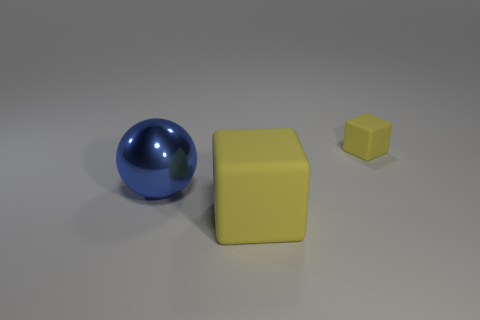What color is the big matte block?
Offer a terse response. Yellow. What is the color of the object on the right side of the yellow thing in front of the blue sphere?
Give a very brief answer. Yellow. There is a tiny block; does it have the same color as the matte object in front of the tiny rubber object?
Make the answer very short. Yes. What number of matte blocks are behind the large yellow matte block in front of the matte cube behind the sphere?
Ensure brevity in your answer.  1. There is a blue metallic object; are there any tiny yellow rubber things in front of it?
Make the answer very short. No. Are there any other things of the same color as the large rubber thing?
Your response must be concise. Yes. What number of cylinders are yellow rubber things or big rubber objects?
Your answer should be compact. 0. How many objects are both on the left side of the small rubber cube and on the right side of the shiny thing?
Ensure brevity in your answer.  1. Are there the same number of large blocks on the right side of the large metal object and tiny yellow blocks that are on the left side of the small rubber thing?
Your answer should be compact. No. Does the yellow object that is in front of the small yellow block have the same shape as the large blue metal object?
Keep it short and to the point. No. 